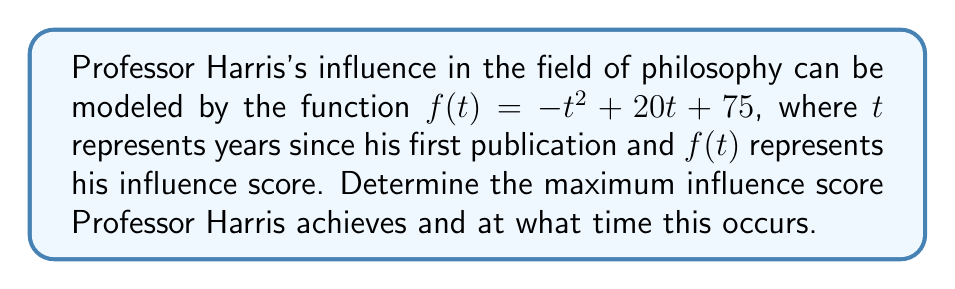Teach me how to tackle this problem. To find the maximum influence of Professor Harris's ideas, we need to optimize the given function. This is a perfect application of derivatives.

Step 1: Identify the function
$f(t) = -t^2 + 20t + 75$

Step 2: Find the derivative
$f'(t) = -2t + 20$

Step 3: Set the derivative equal to zero to find critical points
$f'(t) = 0$
$-2t + 20 = 0$
$-2t = -20$
$t = 10$

Step 4: Verify this is a maximum (not a minimum)
The second derivative $f''(t) = -2$ is negative, confirming this is a maximum.

Step 5: Calculate the maximum influence score
$f(10) = -(10)^2 + 20(10) + 75$
$= -100 + 200 + 75$
$= 175$

Therefore, Professor Harris's influence reaches its maximum after 10 years, with an influence score of 175.
Answer: Maximum influence score: 175; Time: 10 years after first publication 